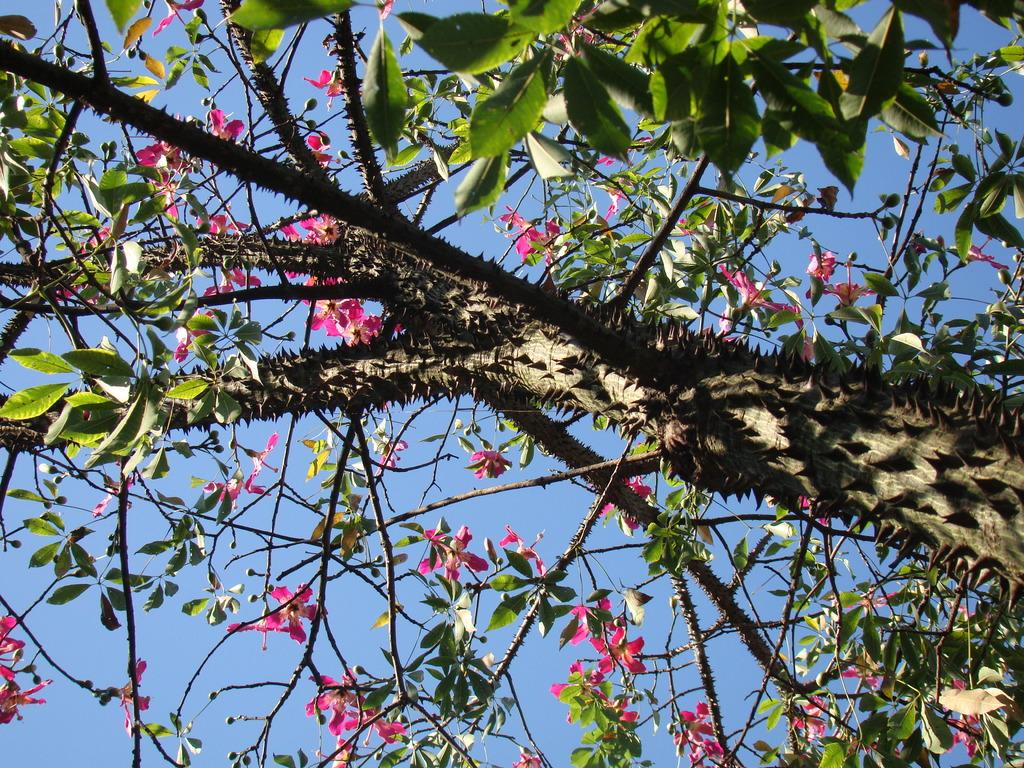What type of plant can be seen in the image? There is a tree in the image. What are the characteristics of the tree? The tree has flowers and leaves. What is visible behind the tree in the image? The sky is visible behind the tree in the image. Can you see any cats climbing the tree in the image? There are no cats present in the image, and therefore no such activity can be observed. What type of berry can be seen growing on the tree in the image? There is no mention of berries in the image; the tree is described as having flowers and leaves. 